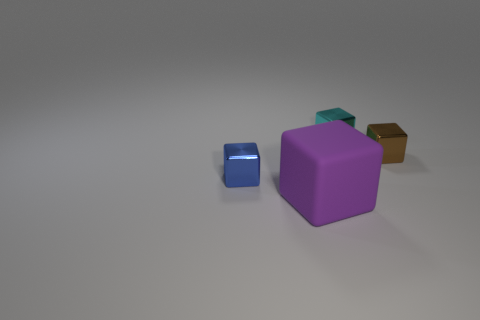Is there any other thing that is the same size as the purple block?
Offer a terse response. No. Are there any other things that are the same material as the big block?
Ensure brevity in your answer.  No. Are there any blue blocks of the same size as the cyan shiny block?
Offer a terse response. Yes. What is the size of the shiny object that is left of the big purple object?
Your answer should be very brief. Small. There is a block that is left of the large purple matte object; is there a metal thing that is right of it?
Keep it short and to the point. Yes. What number of other things are there of the same shape as the big purple matte thing?
Keep it short and to the point. 3. There is a thing that is behind the purple matte object and in front of the tiny brown metal block; what color is it?
Ensure brevity in your answer.  Blue. How many tiny objects are either brown shiny cubes or yellow metallic cylinders?
Ensure brevity in your answer.  1. Is there anything else that has the same color as the matte block?
Offer a very short reply. No. The tiny cube to the left of the block in front of the tiny blue shiny object behind the purple object is made of what material?
Keep it short and to the point. Metal. 